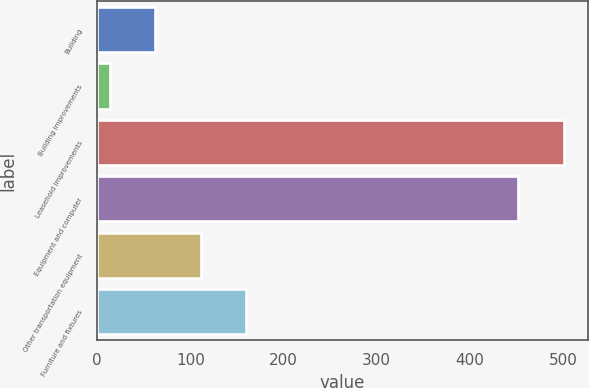Convert chart to OTSL. <chart><loc_0><loc_0><loc_500><loc_500><bar_chart><fcel>Building<fcel>Building improvements<fcel>Leasehold improvements<fcel>Equipment and computer<fcel>Other transportation equipment<fcel>Furniture and fixtures<nl><fcel>62.7<fcel>14<fcel>501<fcel>451<fcel>111.4<fcel>160.1<nl></chart> 